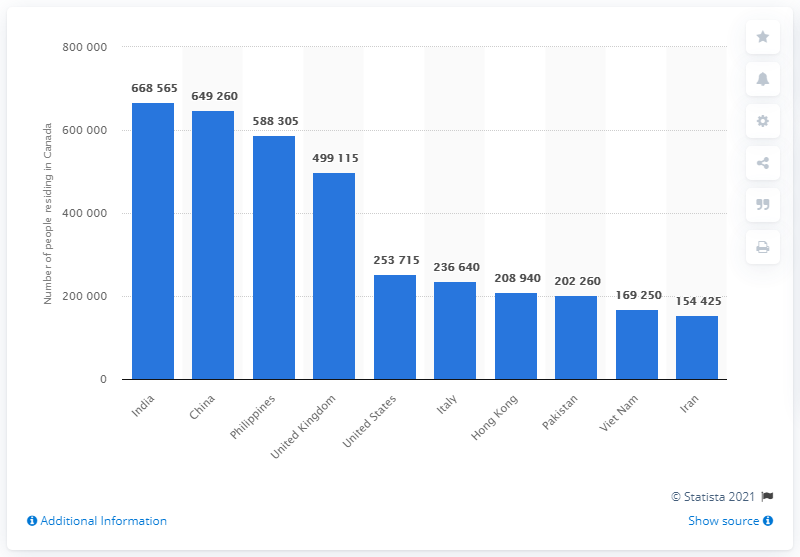List a handful of essential elements in this visual. In 2016, a total of 668,565 people were born in Canada, and the majority of them were born in India. 